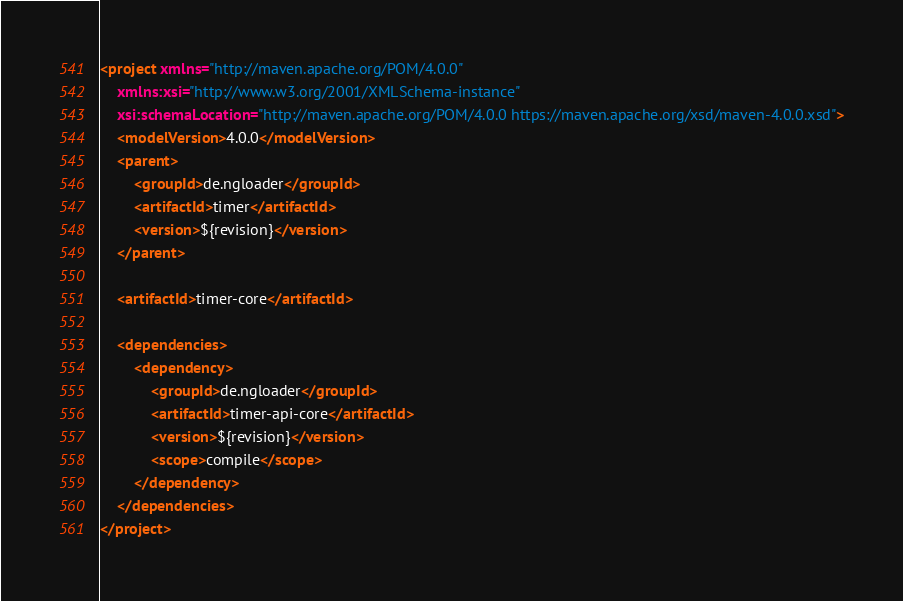<code> <loc_0><loc_0><loc_500><loc_500><_XML_><project xmlns="http://maven.apache.org/POM/4.0.0"
	xmlns:xsi="http://www.w3.org/2001/XMLSchema-instance"
	xsi:schemaLocation="http://maven.apache.org/POM/4.0.0 https://maven.apache.org/xsd/maven-4.0.0.xsd">
	<modelVersion>4.0.0</modelVersion>
	<parent>
		<groupId>de.ngloader</groupId>
		<artifactId>timer</artifactId>
		<version>${revision}</version>
	</parent>

	<artifactId>timer-core</artifactId>

	<dependencies>
		<dependency>
			<groupId>de.ngloader</groupId>
			<artifactId>timer-api-core</artifactId>
			<version>${revision}</version>
			<scope>compile</scope>
		</dependency>
	</dependencies>
</project></code> 